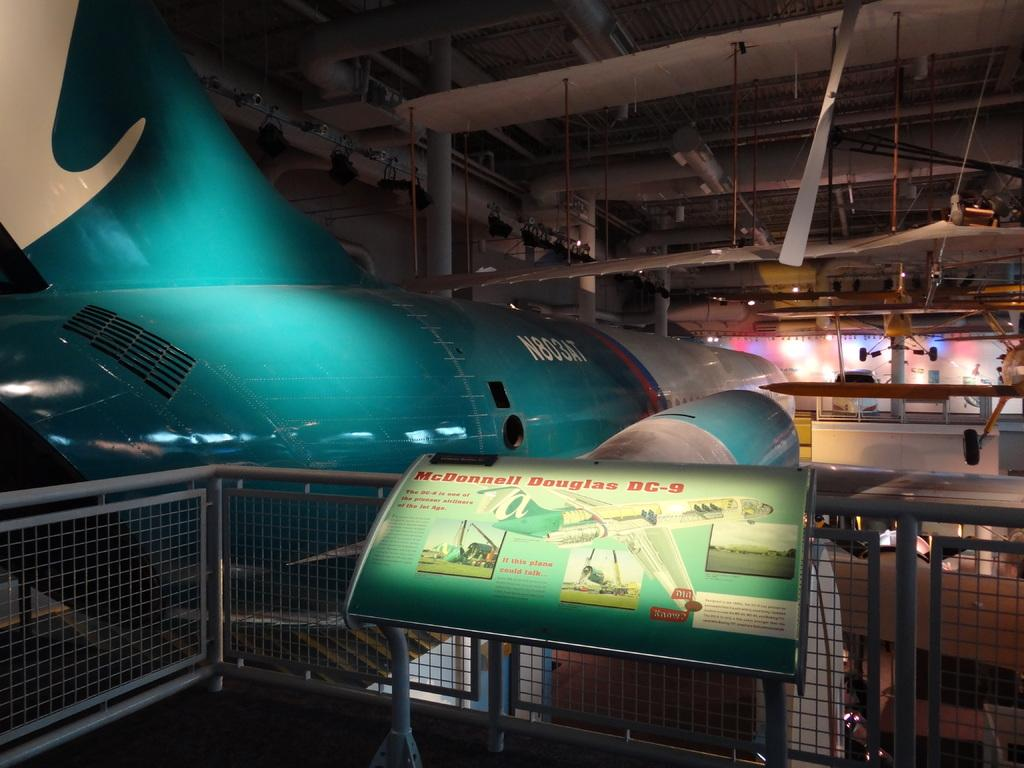<image>
Provide a brief description of the given image. A photo of an area that has DC-9 at the end of it 